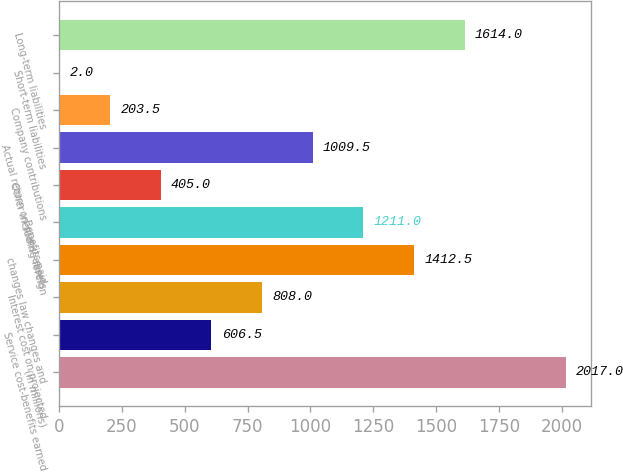Convert chart. <chart><loc_0><loc_0><loc_500><loc_500><bar_chart><fcel>(in millions)<fcel>Service cost-benefits earned<fcel>Interest cost on projected<fcel>changes law changes and<fcel>Benefits paid<fcel>Other including foreign<fcel>Actual return on plans' assets<fcel>Company contributions<fcel>Short-term liabilities<fcel>Long-term liabilities<nl><fcel>2017<fcel>606.5<fcel>808<fcel>1412.5<fcel>1211<fcel>405<fcel>1009.5<fcel>203.5<fcel>2<fcel>1614<nl></chart> 